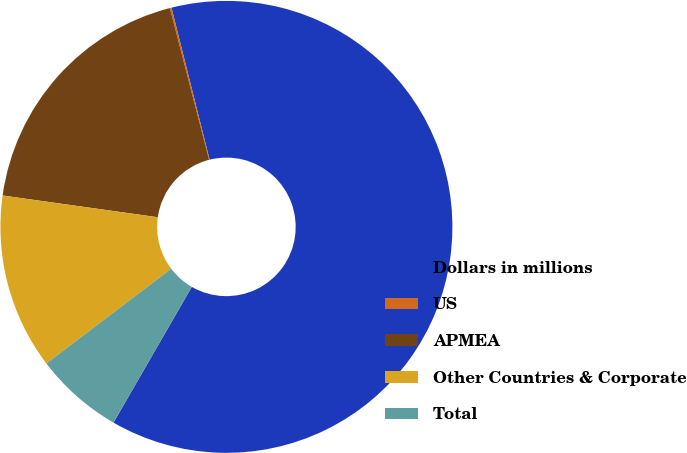Convert chart. <chart><loc_0><loc_0><loc_500><loc_500><pie_chart><fcel>Dollars in millions<fcel>US<fcel>APMEA<fcel>Other Countries & Corporate<fcel>Total<nl><fcel>62.24%<fcel>0.12%<fcel>18.76%<fcel>12.55%<fcel>6.34%<nl></chart> 